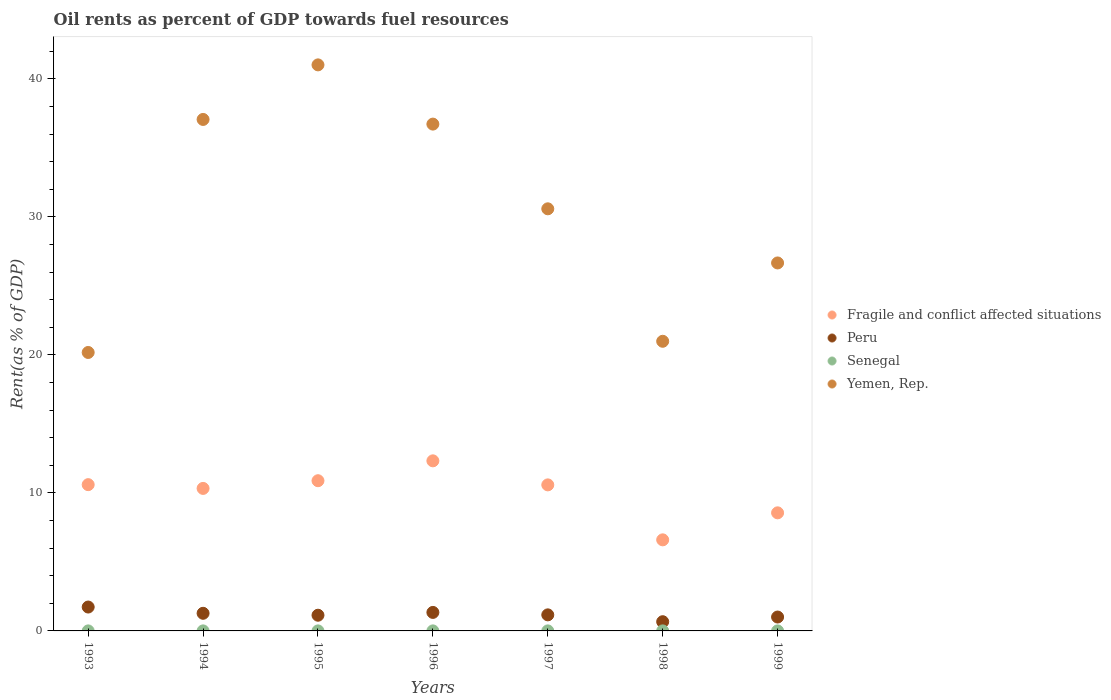How many different coloured dotlines are there?
Your answer should be compact. 4. Is the number of dotlines equal to the number of legend labels?
Make the answer very short. Yes. What is the oil rent in Senegal in 1998?
Provide a short and direct response. 0. Across all years, what is the maximum oil rent in Yemen, Rep.?
Keep it short and to the point. 41.02. Across all years, what is the minimum oil rent in Senegal?
Give a very brief answer. 0. What is the total oil rent in Senegal in the graph?
Offer a very short reply. 0.02. What is the difference between the oil rent in Peru in 1993 and that in 1997?
Keep it short and to the point. 0.57. What is the difference between the oil rent in Yemen, Rep. in 1998 and the oil rent in Fragile and conflict affected situations in 1994?
Ensure brevity in your answer.  10.66. What is the average oil rent in Fragile and conflict affected situations per year?
Make the answer very short. 9.98. In the year 1997, what is the difference between the oil rent in Fragile and conflict affected situations and oil rent in Peru?
Keep it short and to the point. 9.42. What is the ratio of the oil rent in Senegal in 1998 to that in 1999?
Offer a very short reply. 1.41. Is the oil rent in Fragile and conflict affected situations in 1996 less than that in 1999?
Your answer should be compact. No. Is the difference between the oil rent in Fragile and conflict affected situations in 1998 and 1999 greater than the difference between the oil rent in Peru in 1998 and 1999?
Offer a terse response. No. What is the difference between the highest and the second highest oil rent in Peru?
Your response must be concise. 0.39. What is the difference between the highest and the lowest oil rent in Yemen, Rep.?
Your response must be concise. 20.84. In how many years, is the oil rent in Peru greater than the average oil rent in Peru taken over all years?
Your response must be concise. 3. Is the oil rent in Senegal strictly less than the oil rent in Fragile and conflict affected situations over the years?
Provide a succinct answer. Yes. How many years are there in the graph?
Give a very brief answer. 7. Are the values on the major ticks of Y-axis written in scientific E-notation?
Offer a terse response. No. Does the graph contain grids?
Provide a succinct answer. No. Where does the legend appear in the graph?
Offer a very short reply. Center right. How are the legend labels stacked?
Provide a short and direct response. Vertical. What is the title of the graph?
Provide a short and direct response. Oil rents as percent of GDP towards fuel resources. Does "Cayman Islands" appear as one of the legend labels in the graph?
Keep it short and to the point. No. What is the label or title of the Y-axis?
Give a very brief answer. Rent(as % of GDP). What is the Rent(as % of GDP) of Fragile and conflict affected situations in 1993?
Provide a short and direct response. 10.6. What is the Rent(as % of GDP) of Peru in 1993?
Your answer should be compact. 1.73. What is the Rent(as % of GDP) in Senegal in 1993?
Offer a terse response. 0. What is the Rent(as % of GDP) of Yemen, Rep. in 1993?
Offer a terse response. 20.18. What is the Rent(as % of GDP) in Fragile and conflict affected situations in 1994?
Offer a terse response. 10.33. What is the Rent(as % of GDP) of Peru in 1994?
Offer a terse response. 1.28. What is the Rent(as % of GDP) in Senegal in 1994?
Ensure brevity in your answer.  0. What is the Rent(as % of GDP) of Yemen, Rep. in 1994?
Your answer should be compact. 37.06. What is the Rent(as % of GDP) of Fragile and conflict affected situations in 1995?
Provide a short and direct response. 10.88. What is the Rent(as % of GDP) in Peru in 1995?
Ensure brevity in your answer.  1.14. What is the Rent(as % of GDP) in Senegal in 1995?
Your answer should be very brief. 0. What is the Rent(as % of GDP) in Yemen, Rep. in 1995?
Offer a very short reply. 41.02. What is the Rent(as % of GDP) of Fragile and conflict affected situations in 1996?
Your response must be concise. 12.32. What is the Rent(as % of GDP) of Peru in 1996?
Offer a very short reply. 1.34. What is the Rent(as % of GDP) in Senegal in 1996?
Make the answer very short. 0. What is the Rent(as % of GDP) in Yemen, Rep. in 1996?
Ensure brevity in your answer.  36.72. What is the Rent(as % of GDP) of Fragile and conflict affected situations in 1997?
Provide a succinct answer. 10.58. What is the Rent(as % of GDP) of Peru in 1997?
Your answer should be very brief. 1.16. What is the Rent(as % of GDP) in Senegal in 1997?
Your answer should be very brief. 0. What is the Rent(as % of GDP) of Yemen, Rep. in 1997?
Your response must be concise. 30.59. What is the Rent(as % of GDP) of Fragile and conflict affected situations in 1998?
Your answer should be compact. 6.6. What is the Rent(as % of GDP) of Peru in 1998?
Ensure brevity in your answer.  0.67. What is the Rent(as % of GDP) of Senegal in 1998?
Ensure brevity in your answer.  0. What is the Rent(as % of GDP) of Yemen, Rep. in 1998?
Provide a short and direct response. 20.99. What is the Rent(as % of GDP) in Fragile and conflict affected situations in 1999?
Your response must be concise. 8.56. What is the Rent(as % of GDP) in Peru in 1999?
Provide a succinct answer. 1.01. What is the Rent(as % of GDP) in Senegal in 1999?
Your answer should be very brief. 0. What is the Rent(as % of GDP) in Yemen, Rep. in 1999?
Offer a terse response. 26.66. Across all years, what is the maximum Rent(as % of GDP) of Fragile and conflict affected situations?
Give a very brief answer. 12.32. Across all years, what is the maximum Rent(as % of GDP) in Peru?
Ensure brevity in your answer.  1.73. Across all years, what is the maximum Rent(as % of GDP) in Senegal?
Provide a short and direct response. 0. Across all years, what is the maximum Rent(as % of GDP) of Yemen, Rep.?
Offer a very short reply. 41.02. Across all years, what is the minimum Rent(as % of GDP) in Fragile and conflict affected situations?
Ensure brevity in your answer.  6.6. Across all years, what is the minimum Rent(as % of GDP) of Peru?
Your answer should be compact. 0.67. Across all years, what is the minimum Rent(as % of GDP) of Senegal?
Ensure brevity in your answer.  0. Across all years, what is the minimum Rent(as % of GDP) in Yemen, Rep.?
Provide a succinct answer. 20.18. What is the total Rent(as % of GDP) of Fragile and conflict affected situations in the graph?
Offer a very short reply. 69.87. What is the total Rent(as % of GDP) of Peru in the graph?
Provide a short and direct response. 8.32. What is the total Rent(as % of GDP) of Senegal in the graph?
Provide a short and direct response. 0.02. What is the total Rent(as % of GDP) in Yemen, Rep. in the graph?
Offer a very short reply. 213.21. What is the difference between the Rent(as % of GDP) of Fragile and conflict affected situations in 1993 and that in 1994?
Provide a short and direct response. 0.27. What is the difference between the Rent(as % of GDP) in Peru in 1993 and that in 1994?
Give a very brief answer. 0.45. What is the difference between the Rent(as % of GDP) of Senegal in 1993 and that in 1994?
Ensure brevity in your answer.  -0. What is the difference between the Rent(as % of GDP) in Yemen, Rep. in 1993 and that in 1994?
Provide a succinct answer. -16.88. What is the difference between the Rent(as % of GDP) of Fragile and conflict affected situations in 1993 and that in 1995?
Your answer should be compact. -0.28. What is the difference between the Rent(as % of GDP) in Peru in 1993 and that in 1995?
Your answer should be compact. 0.59. What is the difference between the Rent(as % of GDP) of Senegal in 1993 and that in 1995?
Give a very brief answer. -0. What is the difference between the Rent(as % of GDP) in Yemen, Rep. in 1993 and that in 1995?
Make the answer very short. -20.84. What is the difference between the Rent(as % of GDP) of Fragile and conflict affected situations in 1993 and that in 1996?
Your answer should be very brief. -1.73. What is the difference between the Rent(as % of GDP) of Peru in 1993 and that in 1996?
Ensure brevity in your answer.  0.39. What is the difference between the Rent(as % of GDP) in Senegal in 1993 and that in 1996?
Your response must be concise. -0. What is the difference between the Rent(as % of GDP) of Yemen, Rep. in 1993 and that in 1996?
Give a very brief answer. -16.55. What is the difference between the Rent(as % of GDP) of Fragile and conflict affected situations in 1993 and that in 1997?
Offer a very short reply. 0.02. What is the difference between the Rent(as % of GDP) in Peru in 1993 and that in 1997?
Your answer should be compact. 0.57. What is the difference between the Rent(as % of GDP) in Senegal in 1993 and that in 1997?
Offer a very short reply. -0. What is the difference between the Rent(as % of GDP) in Yemen, Rep. in 1993 and that in 1997?
Make the answer very short. -10.41. What is the difference between the Rent(as % of GDP) in Fragile and conflict affected situations in 1993 and that in 1998?
Your answer should be very brief. 4. What is the difference between the Rent(as % of GDP) in Peru in 1993 and that in 1998?
Offer a terse response. 1.06. What is the difference between the Rent(as % of GDP) in Senegal in 1993 and that in 1998?
Your answer should be very brief. -0. What is the difference between the Rent(as % of GDP) of Yemen, Rep. in 1993 and that in 1998?
Make the answer very short. -0.81. What is the difference between the Rent(as % of GDP) in Fragile and conflict affected situations in 1993 and that in 1999?
Your response must be concise. 2.04. What is the difference between the Rent(as % of GDP) in Peru in 1993 and that in 1999?
Give a very brief answer. 0.72. What is the difference between the Rent(as % of GDP) of Senegal in 1993 and that in 1999?
Ensure brevity in your answer.  -0. What is the difference between the Rent(as % of GDP) in Yemen, Rep. in 1993 and that in 1999?
Ensure brevity in your answer.  -6.49. What is the difference between the Rent(as % of GDP) in Fragile and conflict affected situations in 1994 and that in 1995?
Give a very brief answer. -0.56. What is the difference between the Rent(as % of GDP) of Peru in 1994 and that in 1995?
Provide a succinct answer. 0.14. What is the difference between the Rent(as % of GDP) in Senegal in 1994 and that in 1995?
Provide a short and direct response. 0. What is the difference between the Rent(as % of GDP) in Yemen, Rep. in 1994 and that in 1995?
Ensure brevity in your answer.  -3.95. What is the difference between the Rent(as % of GDP) in Fragile and conflict affected situations in 1994 and that in 1996?
Ensure brevity in your answer.  -2. What is the difference between the Rent(as % of GDP) in Peru in 1994 and that in 1996?
Give a very brief answer. -0.06. What is the difference between the Rent(as % of GDP) of Senegal in 1994 and that in 1996?
Your response must be concise. -0. What is the difference between the Rent(as % of GDP) of Yemen, Rep. in 1994 and that in 1996?
Keep it short and to the point. 0.34. What is the difference between the Rent(as % of GDP) in Fragile and conflict affected situations in 1994 and that in 1997?
Offer a terse response. -0.26. What is the difference between the Rent(as % of GDP) of Peru in 1994 and that in 1997?
Ensure brevity in your answer.  0.11. What is the difference between the Rent(as % of GDP) in Senegal in 1994 and that in 1997?
Your answer should be compact. -0. What is the difference between the Rent(as % of GDP) in Yemen, Rep. in 1994 and that in 1997?
Offer a terse response. 6.48. What is the difference between the Rent(as % of GDP) in Fragile and conflict affected situations in 1994 and that in 1998?
Offer a very short reply. 3.73. What is the difference between the Rent(as % of GDP) of Peru in 1994 and that in 1998?
Offer a very short reply. 0.61. What is the difference between the Rent(as % of GDP) of Senegal in 1994 and that in 1998?
Provide a short and direct response. -0. What is the difference between the Rent(as % of GDP) in Yemen, Rep. in 1994 and that in 1998?
Give a very brief answer. 16.07. What is the difference between the Rent(as % of GDP) in Fragile and conflict affected situations in 1994 and that in 1999?
Provide a short and direct response. 1.77. What is the difference between the Rent(as % of GDP) of Peru in 1994 and that in 1999?
Offer a terse response. 0.27. What is the difference between the Rent(as % of GDP) in Senegal in 1994 and that in 1999?
Your answer should be compact. 0. What is the difference between the Rent(as % of GDP) of Yemen, Rep. in 1994 and that in 1999?
Make the answer very short. 10.4. What is the difference between the Rent(as % of GDP) in Fragile and conflict affected situations in 1995 and that in 1996?
Ensure brevity in your answer.  -1.44. What is the difference between the Rent(as % of GDP) of Peru in 1995 and that in 1996?
Provide a short and direct response. -0.2. What is the difference between the Rent(as % of GDP) of Senegal in 1995 and that in 1996?
Your response must be concise. -0. What is the difference between the Rent(as % of GDP) of Yemen, Rep. in 1995 and that in 1996?
Keep it short and to the point. 4.29. What is the difference between the Rent(as % of GDP) of Fragile and conflict affected situations in 1995 and that in 1997?
Ensure brevity in your answer.  0.3. What is the difference between the Rent(as % of GDP) of Peru in 1995 and that in 1997?
Offer a terse response. -0.03. What is the difference between the Rent(as % of GDP) in Senegal in 1995 and that in 1997?
Keep it short and to the point. -0. What is the difference between the Rent(as % of GDP) of Yemen, Rep. in 1995 and that in 1997?
Your answer should be very brief. 10.43. What is the difference between the Rent(as % of GDP) of Fragile and conflict affected situations in 1995 and that in 1998?
Make the answer very short. 4.28. What is the difference between the Rent(as % of GDP) in Peru in 1995 and that in 1998?
Your answer should be compact. 0.47. What is the difference between the Rent(as % of GDP) of Senegal in 1995 and that in 1998?
Give a very brief answer. -0. What is the difference between the Rent(as % of GDP) in Yemen, Rep. in 1995 and that in 1998?
Give a very brief answer. 20.03. What is the difference between the Rent(as % of GDP) in Fragile and conflict affected situations in 1995 and that in 1999?
Your response must be concise. 2.33. What is the difference between the Rent(as % of GDP) in Peru in 1995 and that in 1999?
Offer a terse response. 0.13. What is the difference between the Rent(as % of GDP) in Yemen, Rep. in 1995 and that in 1999?
Provide a succinct answer. 14.35. What is the difference between the Rent(as % of GDP) of Fragile and conflict affected situations in 1996 and that in 1997?
Your answer should be compact. 1.74. What is the difference between the Rent(as % of GDP) in Peru in 1996 and that in 1997?
Offer a terse response. 0.18. What is the difference between the Rent(as % of GDP) in Yemen, Rep. in 1996 and that in 1997?
Provide a short and direct response. 6.14. What is the difference between the Rent(as % of GDP) of Fragile and conflict affected situations in 1996 and that in 1998?
Keep it short and to the point. 5.72. What is the difference between the Rent(as % of GDP) in Peru in 1996 and that in 1998?
Your answer should be compact. 0.67. What is the difference between the Rent(as % of GDP) in Senegal in 1996 and that in 1998?
Give a very brief answer. -0. What is the difference between the Rent(as % of GDP) in Yemen, Rep. in 1996 and that in 1998?
Offer a terse response. 15.74. What is the difference between the Rent(as % of GDP) in Fragile and conflict affected situations in 1996 and that in 1999?
Your answer should be very brief. 3.77. What is the difference between the Rent(as % of GDP) of Peru in 1996 and that in 1999?
Your response must be concise. 0.33. What is the difference between the Rent(as % of GDP) in Yemen, Rep. in 1996 and that in 1999?
Offer a very short reply. 10.06. What is the difference between the Rent(as % of GDP) in Fragile and conflict affected situations in 1997 and that in 1998?
Provide a succinct answer. 3.98. What is the difference between the Rent(as % of GDP) of Peru in 1997 and that in 1998?
Make the answer very short. 0.5. What is the difference between the Rent(as % of GDP) of Senegal in 1997 and that in 1998?
Your answer should be very brief. -0. What is the difference between the Rent(as % of GDP) in Yemen, Rep. in 1997 and that in 1998?
Provide a succinct answer. 9.6. What is the difference between the Rent(as % of GDP) in Fragile and conflict affected situations in 1997 and that in 1999?
Make the answer very short. 2.03. What is the difference between the Rent(as % of GDP) in Peru in 1997 and that in 1999?
Provide a short and direct response. 0.16. What is the difference between the Rent(as % of GDP) of Yemen, Rep. in 1997 and that in 1999?
Make the answer very short. 3.92. What is the difference between the Rent(as % of GDP) of Fragile and conflict affected situations in 1998 and that in 1999?
Your response must be concise. -1.96. What is the difference between the Rent(as % of GDP) in Peru in 1998 and that in 1999?
Your answer should be very brief. -0.34. What is the difference between the Rent(as % of GDP) in Senegal in 1998 and that in 1999?
Offer a very short reply. 0. What is the difference between the Rent(as % of GDP) in Yemen, Rep. in 1998 and that in 1999?
Your response must be concise. -5.68. What is the difference between the Rent(as % of GDP) in Fragile and conflict affected situations in 1993 and the Rent(as % of GDP) in Peru in 1994?
Provide a succinct answer. 9.32. What is the difference between the Rent(as % of GDP) in Fragile and conflict affected situations in 1993 and the Rent(as % of GDP) in Senegal in 1994?
Make the answer very short. 10.6. What is the difference between the Rent(as % of GDP) in Fragile and conflict affected situations in 1993 and the Rent(as % of GDP) in Yemen, Rep. in 1994?
Offer a terse response. -26.46. What is the difference between the Rent(as % of GDP) of Peru in 1993 and the Rent(as % of GDP) of Senegal in 1994?
Make the answer very short. 1.73. What is the difference between the Rent(as % of GDP) in Peru in 1993 and the Rent(as % of GDP) in Yemen, Rep. in 1994?
Your response must be concise. -35.33. What is the difference between the Rent(as % of GDP) in Senegal in 1993 and the Rent(as % of GDP) in Yemen, Rep. in 1994?
Offer a very short reply. -37.06. What is the difference between the Rent(as % of GDP) of Fragile and conflict affected situations in 1993 and the Rent(as % of GDP) of Peru in 1995?
Keep it short and to the point. 9.46. What is the difference between the Rent(as % of GDP) in Fragile and conflict affected situations in 1993 and the Rent(as % of GDP) in Senegal in 1995?
Offer a very short reply. 10.6. What is the difference between the Rent(as % of GDP) of Fragile and conflict affected situations in 1993 and the Rent(as % of GDP) of Yemen, Rep. in 1995?
Your response must be concise. -30.42. What is the difference between the Rent(as % of GDP) in Peru in 1993 and the Rent(as % of GDP) in Senegal in 1995?
Your response must be concise. 1.73. What is the difference between the Rent(as % of GDP) in Peru in 1993 and the Rent(as % of GDP) in Yemen, Rep. in 1995?
Ensure brevity in your answer.  -39.28. What is the difference between the Rent(as % of GDP) of Senegal in 1993 and the Rent(as % of GDP) of Yemen, Rep. in 1995?
Make the answer very short. -41.01. What is the difference between the Rent(as % of GDP) of Fragile and conflict affected situations in 1993 and the Rent(as % of GDP) of Peru in 1996?
Your answer should be compact. 9.26. What is the difference between the Rent(as % of GDP) in Fragile and conflict affected situations in 1993 and the Rent(as % of GDP) in Senegal in 1996?
Offer a terse response. 10.6. What is the difference between the Rent(as % of GDP) in Fragile and conflict affected situations in 1993 and the Rent(as % of GDP) in Yemen, Rep. in 1996?
Provide a succinct answer. -26.12. What is the difference between the Rent(as % of GDP) in Peru in 1993 and the Rent(as % of GDP) in Senegal in 1996?
Give a very brief answer. 1.73. What is the difference between the Rent(as % of GDP) of Peru in 1993 and the Rent(as % of GDP) of Yemen, Rep. in 1996?
Offer a terse response. -34.99. What is the difference between the Rent(as % of GDP) of Senegal in 1993 and the Rent(as % of GDP) of Yemen, Rep. in 1996?
Give a very brief answer. -36.72. What is the difference between the Rent(as % of GDP) of Fragile and conflict affected situations in 1993 and the Rent(as % of GDP) of Peru in 1997?
Your answer should be very brief. 9.43. What is the difference between the Rent(as % of GDP) of Fragile and conflict affected situations in 1993 and the Rent(as % of GDP) of Senegal in 1997?
Your response must be concise. 10.6. What is the difference between the Rent(as % of GDP) in Fragile and conflict affected situations in 1993 and the Rent(as % of GDP) in Yemen, Rep. in 1997?
Your response must be concise. -19.99. What is the difference between the Rent(as % of GDP) of Peru in 1993 and the Rent(as % of GDP) of Senegal in 1997?
Make the answer very short. 1.73. What is the difference between the Rent(as % of GDP) of Peru in 1993 and the Rent(as % of GDP) of Yemen, Rep. in 1997?
Make the answer very short. -28.86. What is the difference between the Rent(as % of GDP) of Senegal in 1993 and the Rent(as % of GDP) of Yemen, Rep. in 1997?
Give a very brief answer. -30.58. What is the difference between the Rent(as % of GDP) of Fragile and conflict affected situations in 1993 and the Rent(as % of GDP) of Peru in 1998?
Offer a terse response. 9.93. What is the difference between the Rent(as % of GDP) of Fragile and conflict affected situations in 1993 and the Rent(as % of GDP) of Senegal in 1998?
Offer a terse response. 10.6. What is the difference between the Rent(as % of GDP) in Fragile and conflict affected situations in 1993 and the Rent(as % of GDP) in Yemen, Rep. in 1998?
Keep it short and to the point. -10.39. What is the difference between the Rent(as % of GDP) of Peru in 1993 and the Rent(as % of GDP) of Senegal in 1998?
Offer a very short reply. 1.73. What is the difference between the Rent(as % of GDP) in Peru in 1993 and the Rent(as % of GDP) in Yemen, Rep. in 1998?
Offer a very short reply. -19.26. What is the difference between the Rent(as % of GDP) in Senegal in 1993 and the Rent(as % of GDP) in Yemen, Rep. in 1998?
Provide a short and direct response. -20.99. What is the difference between the Rent(as % of GDP) in Fragile and conflict affected situations in 1993 and the Rent(as % of GDP) in Peru in 1999?
Provide a short and direct response. 9.59. What is the difference between the Rent(as % of GDP) in Fragile and conflict affected situations in 1993 and the Rent(as % of GDP) in Senegal in 1999?
Offer a terse response. 10.6. What is the difference between the Rent(as % of GDP) of Fragile and conflict affected situations in 1993 and the Rent(as % of GDP) of Yemen, Rep. in 1999?
Your response must be concise. -16.06. What is the difference between the Rent(as % of GDP) of Peru in 1993 and the Rent(as % of GDP) of Senegal in 1999?
Provide a short and direct response. 1.73. What is the difference between the Rent(as % of GDP) of Peru in 1993 and the Rent(as % of GDP) of Yemen, Rep. in 1999?
Offer a very short reply. -24.93. What is the difference between the Rent(as % of GDP) in Senegal in 1993 and the Rent(as % of GDP) in Yemen, Rep. in 1999?
Ensure brevity in your answer.  -26.66. What is the difference between the Rent(as % of GDP) of Fragile and conflict affected situations in 1994 and the Rent(as % of GDP) of Peru in 1995?
Give a very brief answer. 9.19. What is the difference between the Rent(as % of GDP) of Fragile and conflict affected situations in 1994 and the Rent(as % of GDP) of Senegal in 1995?
Keep it short and to the point. 10.32. What is the difference between the Rent(as % of GDP) in Fragile and conflict affected situations in 1994 and the Rent(as % of GDP) in Yemen, Rep. in 1995?
Offer a terse response. -30.69. What is the difference between the Rent(as % of GDP) in Peru in 1994 and the Rent(as % of GDP) in Senegal in 1995?
Give a very brief answer. 1.27. What is the difference between the Rent(as % of GDP) of Peru in 1994 and the Rent(as % of GDP) of Yemen, Rep. in 1995?
Your answer should be very brief. -39.74. What is the difference between the Rent(as % of GDP) in Senegal in 1994 and the Rent(as % of GDP) in Yemen, Rep. in 1995?
Provide a short and direct response. -41.01. What is the difference between the Rent(as % of GDP) of Fragile and conflict affected situations in 1994 and the Rent(as % of GDP) of Peru in 1996?
Your answer should be compact. 8.99. What is the difference between the Rent(as % of GDP) in Fragile and conflict affected situations in 1994 and the Rent(as % of GDP) in Senegal in 1996?
Provide a succinct answer. 10.32. What is the difference between the Rent(as % of GDP) of Fragile and conflict affected situations in 1994 and the Rent(as % of GDP) of Yemen, Rep. in 1996?
Your answer should be compact. -26.4. What is the difference between the Rent(as % of GDP) of Peru in 1994 and the Rent(as % of GDP) of Senegal in 1996?
Provide a short and direct response. 1.27. What is the difference between the Rent(as % of GDP) in Peru in 1994 and the Rent(as % of GDP) in Yemen, Rep. in 1996?
Offer a terse response. -35.45. What is the difference between the Rent(as % of GDP) in Senegal in 1994 and the Rent(as % of GDP) in Yemen, Rep. in 1996?
Your answer should be very brief. -36.72. What is the difference between the Rent(as % of GDP) in Fragile and conflict affected situations in 1994 and the Rent(as % of GDP) in Peru in 1997?
Keep it short and to the point. 9.16. What is the difference between the Rent(as % of GDP) in Fragile and conflict affected situations in 1994 and the Rent(as % of GDP) in Senegal in 1997?
Keep it short and to the point. 10.32. What is the difference between the Rent(as % of GDP) of Fragile and conflict affected situations in 1994 and the Rent(as % of GDP) of Yemen, Rep. in 1997?
Provide a short and direct response. -20.26. What is the difference between the Rent(as % of GDP) of Peru in 1994 and the Rent(as % of GDP) of Senegal in 1997?
Provide a succinct answer. 1.27. What is the difference between the Rent(as % of GDP) in Peru in 1994 and the Rent(as % of GDP) in Yemen, Rep. in 1997?
Offer a very short reply. -29.31. What is the difference between the Rent(as % of GDP) of Senegal in 1994 and the Rent(as % of GDP) of Yemen, Rep. in 1997?
Ensure brevity in your answer.  -30.58. What is the difference between the Rent(as % of GDP) in Fragile and conflict affected situations in 1994 and the Rent(as % of GDP) in Peru in 1998?
Provide a short and direct response. 9.66. What is the difference between the Rent(as % of GDP) in Fragile and conflict affected situations in 1994 and the Rent(as % of GDP) in Senegal in 1998?
Provide a succinct answer. 10.32. What is the difference between the Rent(as % of GDP) of Fragile and conflict affected situations in 1994 and the Rent(as % of GDP) of Yemen, Rep. in 1998?
Provide a short and direct response. -10.66. What is the difference between the Rent(as % of GDP) in Peru in 1994 and the Rent(as % of GDP) in Senegal in 1998?
Offer a very short reply. 1.27. What is the difference between the Rent(as % of GDP) of Peru in 1994 and the Rent(as % of GDP) of Yemen, Rep. in 1998?
Offer a very short reply. -19.71. What is the difference between the Rent(as % of GDP) in Senegal in 1994 and the Rent(as % of GDP) in Yemen, Rep. in 1998?
Provide a short and direct response. -20.98. What is the difference between the Rent(as % of GDP) of Fragile and conflict affected situations in 1994 and the Rent(as % of GDP) of Peru in 1999?
Give a very brief answer. 9.32. What is the difference between the Rent(as % of GDP) in Fragile and conflict affected situations in 1994 and the Rent(as % of GDP) in Senegal in 1999?
Keep it short and to the point. 10.32. What is the difference between the Rent(as % of GDP) in Fragile and conflict affected situations in 1994 and the Rent(as % of GDP) in Yemen, Rep. in 1999?
Ensure brevity in your answer.  -16.34. What is the difference between the Rent(as % of GDP) in Peru in 1994 and the Rent(as % of GDP) in Senegal in 1999?
Your answer should be compact. 1.28. What is the difference between the Rent(as % of GDP) of Peru in 1994 and the Rent(as % of GDP) of Yemen, Rep. in 1999?
Keep it short and to the point. -25.39. What is the difference between the Rent(as % of GDP) in Senegal in 1994 and the Rent(as % of GDP) in Yemen, Rep. in 1999?
Give a very brief answer. -26.66. What is the difference between the Rent(as % of GDP) of Fragile and conflict affected situations in 1995 and the Rent(as % of GDP) of Peru in 1996?
Provide a short and direct response. 9.54. What is the difference between the Rent(as % of GDP) in Fragile and conflict affected situations in 1995 and the Rent(as % of GDP) in Senegal in 1996?
Make the answer very short. 10.88. What is the difference between the Rent(as % of GDP) in Fragile and conflict affected situations in 1995 and the Rent(as % of GDP) in Yemen, Rep. in 1996?
Provide a short and direct response. -25.84. What is the difference between the Rent(as % of GDP) of Peru in 1995 and the Rent(as % of GDP) of Senegal in 1996?
Give a very brief answer. 1.14. What is the difference between the Rent(as % of GDP) of Peru in 1995 and the Rent(as % of GDP) of Yemen, Rep. in 1996?
Offer a very short reply. -35.59. What is the difference between the Rent(as % of GDP) in Senegal in 1995 and the Rent(as % of GDP) in Yemen, Rep. in 1996?
Keep it short and to the point. -36.72. What is the difference between the Rent(as % of GDP) of Fragile and conflict affected situations in 1995 and the Rent(as % of GDP) of Peru in 1997?
Provide a short and direct response. 9.72. What is the difference between the Rent(as % of GDP) in Fragile and conflict affected situations in 1995 and the Rent(as % of GDP) in Senegal in 1997?
Give a very brief answer. 10.88. What is the difference between the Rent(as % of GDP) in Fragile and conflict affected situations in 1995 and the Rent(as % of GDP) in Yemen, Rep. in 1997?
Your answer should be compact. -19.7. What is the difference between the Rent(as % of GDP) of Peru in 1995 and the Rent(as % of GDP) of Senegal in 1997?
Your answer should be very brief. 1.14. What is the difference between the Rent(as % of GDP) of Peru in 1995 and the Rent(as % of GDP) of Yemen, Rep. in 1997?
Your answer should be compact. -29.45. What is the difference between the Rent(as % of GDP) of Senegal in 1995 and the Rent(as % of GDP) of Yemen, Rep. in 1997?
Your response must be concise. -30.58. What is the difference between the Rent(as % of GDP) of Fragile and conflict affected situations in 1995 and the Rent(as % of GDP) of Peru in 1998?
Offer a very short reply. 10.22. What is the difference between the Rent(as % of GDP) of Fragile and conflict affected situations in 1995 and the Rent(as % of GDP) of Senegal in 1998?
Keep it short and to the point. 10.88. What is the difference between the Rent(as % of GDP) in Fragile and conflict affected situations in 1995 and the Rent(as % of GDP) in Yemen, Rep. in 1998?
Provide a succinct answer. -10.1. What is the difference between the Rent(as % of GDP) of Peru in 1995 and the Rent(as % of GDP) of Senegal in 1998?
Offer a terse response. 1.13. What is the difference between the Rent(as % of GDP) of Peru in 1995 and the Rent(as % of GDP) of Yemen, Rep. in 1998?
Keep it short and to the point. -19.85. What is the difference between the Rent(as % of GDP) in Senegal in 1995 and the Rent(as % of GDP) in Yemen, Rep. in 1998?
Offer a very short reply. -20.99. What is the difference between the Rent(as % of GDP) in Fragile and conflict affected situations in 1995 and the Rent(as % of GDP) in Peru in 1999?
Keep it short and to the point. 9.88. What is the difference between the Rent(as % of GDP) in Fragile and conflict affected situations in 1995 and the Rent(as % of GDP) in Senegal in 1999?
Your response must be concise. 10.88. What is the difference between the Rent(as % of GDP) in Fragile and conflict affected situations in 1995 and the Rent(as % of GDP) in Yemen, Rep. in 1999?
Your response must be concise. -15.78. What is the difference between the Rent(as % of GDP) in Peru in 1995 and the Rent(as % of GDP) in Senegal in 1999?
Your response must be concise. 1.14. What is the difference between the Rent(as % of GDP) of Peru in 1995 and the Rent(as % of GDP) of Yemen, Rep. in 1999?
Provide a succinct answer. -25.53. What is the difference between the Rent(as % of GDP) in Senegal in 1995 and the Rent(as % of GDP) in Yemen, Rep. in 1999?
Offer a terse response. -26.66. What is the difference between the Rent(as % of GDP) in Fragile and conflict affected situations in 1996 and the Rent(as % of GDP) in Peru in 1997?
Your answer should be compact. 11.16. What is the difference between the Rent(as % of GDP) of Fragile and conflict affected situations in 1996 and the Rent(as % of GDP) of Senegal in 1997?
Keep it short and to the point. 12.32. What is the difference between the Rent(as % of GDP) of Fragile and conflict affected situations in 1996 and the Rent(as % of GDP) of Yemen, Rep. in 1997?
Your answer should be very brief. -18.26. What is the difference between the Rent(as % of GDP) of Peru in 1996 and the Rent(as % of GDP) of Senegal in 1997?
Make the answer very short. 1.34. What is the difference between the Rent(as % of GDP) of Peru in 1996 and the Rent(as % of GDP) of Yemen, Rep. in 1997?
Make the answer very short. -29.25. What is the difference between the Rent(as % of GDP) of Senegal in 1996 and the Rent(as % of GDP) of Yemen, Rep. in 1997?
Make the answer very short. -30.58. What is the difference between the Rent(as % of GDP) in Fragile and conflict affected situations in 1996 and the Rent(as % of GDP) in Peru in 1998?
Keep it short and to the point. 11.66. What is the difference between the Rent(as % of GDP) of Fragile and conflict affected situations in 1996 and the Rent(as % of GDP) of Senegal in 1998?
Ensure brevity in your answer.  12.32. What is the difference between the Rent(as % of GDP) of Fragile and conflict affected situations in 1996 and the Rent(as % of GDP) of Yemen, Rep. in 1998?
Provide a succinct answer. -8.66. What is the difference between the Rent(as % of GDP) in Peru in 1996 and the Rent(as % of GDP) in Senegal in 1998?
Give a very brief answer. 1.34. What is the difference between the Rent(as % of GDP) in Peru in 1996 and the Rent(as % of GDP) in Yemen, Rep. in 1998?
Give a very brief answer. -19.65. What is the difference between the Rent(as % of GDP) of Senegal in 1996 and the Rent(as % of GDP) of Yemen, Rep. in 1998?
Your answer should be very brief. -20.98. What is the difference between the Rent(as % of GDP) in Fragile and conflict affected situations in 1996 and the Rent(as % of GDP) in Peru in 1999?
Your answer should be compact. 11.32. What is the difference between the Rent(as % of GDP) in Fragile and conflict affected situations in 1996 and the Rent(as % of GDP) in Senegal in 1999?
Give a very brief answer. 12.32. What is the difference between the Rent(as % of GDP) of Fragile and conflict affected situations in 1996 and the Rent(as % of GDP) of Yemen, Rep. in 1999?
Give a very brief answer. -14.34. What is the difference between the Rent(as % of GDP) in Peru in 1996 and the Rent(as % of GDP) in Senegal in 1999?
Your answer should be very brief. 1.34. What is the difference between the Rent(as % of GDP) of Peru in 1996 and the Rent(as % of GDP) of Yemen, Rep. in 1999?
Offer a very short reply. -25.32. What is the difference between the Rent(as % of GDP) of Senegal in 1996 and the Rent(as % of GDP) of Yemen, Rep. in 1999?
Offer a very short reply. -26.66. What is the difference between the Rent(as % of GDP) in Fragile and conflict affected situations in 1997 and the Rent(as % of GDP) in Peru in 1998?
Give a very brief answer. 9.91. What is the difference between the Rent(as % of GDP) of Fragile and conflict affected situations in 1997 and the Rent(as % of GDP) of Senegal in 1998?
Your answer should be very brief. 10.58. What is the difference between the Rent(as % of GDP) of Fragile and conflict affected situations in 1997 and the Rent(as % of GDP) of Yemen, Rep. in 1998?
Make the answer very short. -10.4. What is the difference between the Rent(as % of GDP) of Peru in 1997 and the Rent(as % of GDP) of Senegal in 1998?
Provide a short and direct response. 1.16. What is the difference between the Rent(as % of GDP) of Peru in 1997 and the Rent(as % of GDP) of Yemen, Rep. in 1998?
Give a very brief answer. -19.82. What is the difference between the Rent(as % of GDP) in Senegal in 1997 and the Rent(as % of GDP) in Yemen, Rep. in 1998?
Make the answer very short. -20.98. What is the difference between the Rent(as % of GDP) in Fragile and conflict affected situations in 1997 and the Rent(as % of GDP) in Peru in 1999?
Offer a terse response. 9.58. What is the difference between the Rent(as % of GDP) of Fragile and conflict affected situations in 1997 and the Rent(as % of GDP) of Senegal in 1999?
Offer a very short reply. 10.58. What is the difference between the Rent(as % of GDP) in Fragile and conflict affected situations in 1997 and the Rent(as % of GDP) in Yemen, Rep. in 1999?
Offer a terse response. -16.08. What is the difference between the Rent(as % of GDP) of Peru in 1997 and the Rent(as % of GDP) of Senegal in 1999?
Provide a short and direct response. 1.16. What is the difference between the Rent(as % of GDP) in Peru in 1997 and the Rent(as % of GDP) in Yemen, Rep. in 1999?
Ensure brevity in your answer.  -25.5. What is the difference between the Rent(as % of GDP) in Senegal in 1997 and the Rent(as % of GDP) in Yemen, Rep. in 1999?
Provide a short and direct response. -26.66. What is the difference between the Rent(as % of GDP) of Fragile and conflict affected situations in 1998 and the Rent(as % of GDP) of Peru in 1999?
Provide a succinct answer. 5.59. What is the difference between the Rent(as % of GDP) in Fragile and conflict affected situations in 1998 and the Rent(as % of GDP) in Senegal in 1999?
Your answer should be compact. 6.6. What is the difference between the Rent(as % of GDP) of Fragile and conflict affected situations in 1998 and the Rent(as % of GDP) of Yemen, Rep. in 1999?
Your response must be concise. -20.06. What is the difference between the Rent(as % of GDP) in Peru in 1998 and the Rent(as % of GDP) in Senegal in 1999?
Give a very brief answer. 0.67. What is the difference between the Rent(as % of GDP) of Peru in 1998 and the Rent(as % of GDP) of Yemen, Rep. in 1999?
Provide a succinct answer. -26. What is the difference between the Rent(as % of GDP) of Senegal in 1998 and the Rent(as % of GDP) of Yemen, Rep. in 1999?
Ensure brevity in your answer.  -26.66. What is the average Rent(as % of GDP) in Fragile and conflict affected situations per year?
Offer a very short reply. 9.98. What is the average Rent(as % of GDP) of Peru per year?
Offer a terse response. 1.19. What is the average Rent(as % of GDP) in Senegal per year?
Provide a short and direct response. 0. What is the average Rent(as % of GDP) in Yemen, Rep. per year?
Provide a succinct answer. 30.46. In the year 1993, what is the difference between the Rent(as % of GDP) of Fragile and conflict affected situations and Rent(as % of GDP) of Peru?
Your answer should be compact. 8.87. In the year 1993, what is the difference between the Rent(as % of GDP) of Fragile and conflict affected situations and Rent(as % of GDP) of Senegal?
Offer a terse response. 10.6. In the year 1993, what is the difference between the Rent(as % of GDP) of Fragile and conflict affected situations and Rent(as % of GDP) of Yemen, Rep.?
Provide a succinct answer. -9.58. In the year 1993, what is the difference between the Rent(as % of GDP) of Peru and Rent(as % of GDP) of Senegal?
Keep it short and to the point. 1.73. In the year 1993, what is the difference between the Rent(as % of GDP) in Peru and Rent(as % of GDP) in Yemen, Rep.?
Ensure brevity in your answer.  -18.45. In the year 1993, what is the difference between the Rent(as % of GDP) of Senegal and Rent(as % of GDP) of Yemen, Rep.?
Your answer should be very brief. -20.17. In the year 1994, what is the difference between the Rent(as % of GDP) of Fragile and conflict affected situations and Rent(as % of GDP) of Peru?
Offer a terse response. 9.05. In the year 1994, what is the difference between the Rent(as % of GDP) in Fragile and conflict affected situations and Rent(as % of GDP) in Senegal?
Make the answer very short. 10.32. In the year 1994, what is the difference between the Rent(as % of GDP) of Fragile and conflict affected situations and Rent(as % of GDP) of Yemen, Rep.?
Offer a very short reply. -26.74. In the year 1994, what is the difference between the Rent(as % of GDP) of Peru and Rent(as % of GDP) of Senegal?
Offer a very short reply. 1.27. In the year 1994, what is the difference between the Rent(as % of GDP) in Peru and Rent(as % of GDP) in Yemen, Rep.?
Offer a terse response. -35.78. In the year 1994, what is the difference between the Rent(as % of GDP) of Senegal and Rent(as % of GDP) of Yemen, Rep.?
Make the answer very short. -37.06. In the year 1995, what is the difference between the Rent(as % of GDP) of Fragile and conflict affected situations and Rent(as % of GDP) of Peru?
Provide a succinct answer. 9.75. In the year 1995, what is the difference between the Rent(as % of GDP) of Fragile and conflict affected situations and Rent(as % of GDP) of Senegal?
Your answer should be compact. 10.88. In the year 1995, what is the difference between the Rent(as % of GDP) of Fragile and conflict affected situations and Rent(as % of GDP) of Yemen, Rep.?
Offer a terse response. -30.13. In the year 1995, what is the difference between the Rent(as % of GDP) in Peru and Rent(as % of GDP) in Senegal?
Provide a succinct answer. 1.14. In the year 1995, what is the difference between the Rent(as % of GDP) of Peru and Rent(as % of GDP) of Yemen, Rep.?
Provide a short and direct response. -39.88. In the year 1995, what is the difference between the Rent(as % of GDP) of Senegal and Rent(as % of GDP) of Yemen, Rep.?
Ensure brevity in your answer.  -41.01. In the year 1996, what is the difference between the Rent(as % of GDP) of Fragile and conflict affected situations and Rent(as % of GDP) of Peru?
Provide a short and direct response. 10.98. In the year 1996, what is the difference between the Rent(as % of GDP) in Fragile and conflict affected situations and Rent(as % of GDP) in Senegal?
Provide a short and direct response. 12.32. In the year 1996, what is the difference between the Rent(as % of GDP) in Fragile and conflict affected situations and Rent(as % of GDP) in Yemen, Rep.?
Give a very brief answer. -24.4. In the year 1996, what is the difference between the Rent(as % of GDP) in Peru and Rent(as % of GDP) in Senegal?
Give a very brief answer. 1.34. In the year 1996, what is the difference between the Rent(as % of GDP) of Peru and Rent(as % of GDP) of Yemen, Rep.?
Make the answer very short. -35.38. In the year 1996, what is the difference between the Rent(as % of GDP) of Senegal and Rent(as % of GDP) of Yemen, Rep.?
Provide a short and direct response. -36.72. In the year 1997, what is the difference between the Rent(as % of GDP) in Fragile and conflict affected situations and Rent(as % of GDP) in Peru?
Your answer should be very brief. 9.42. In the year 1997, what is the difference between the Rent(as % of GDP) in Fragile and conflict affected situations and Rent(as % of GDP) in Senegal?
Offer a terse response. 10.58. In the year 1997, what is the difference between the Rent(as % of GDP) of Fragile and conflict affected situations and Rent(as % of GDP) of Yemen, Rep.?
Offer a terse response. -20. In the year 1997, what is the difference between the Rent(as % of GDP) of Peru and Rent(as % of GDP) of Senegal?
Make the answer very short. 1.16. In the year 1997, what is the difference between the Rent(as % of GDP) in Peru and Rent(as % of GDP) in Yemen, Rep.?
Give a very brief answer. -29.42. In the year 1997, what is the difference between the Rent(as % of GDP) of Senegal and Rent(as % of GDP) of Yemen, Rep.?
Offer a very short reply. -30.58. In the year 1998, what is the difference between the Rent(as % of GDP) of Fragile and conflict affected situations and Rent(as % of GDP) of Peru?
Ensure brevity in your answer.  5.93. In the year 1998, what is the difference between the Rent(as % of GDP) in Fragile and conflict affected situations and Rent(as % of GDP) in Senegal?
Ensure brevity in your answer.  6.6. In the year 1998, what is the difference between the Rent(as % of GDP) in Fragile and conflict affected situations and Rent(as % of GDP) in Yemen, Rep.?
Your answer should be very brief. -14.39. In the year 1998, what is the difference between the Rent(as % of GDP) of Peru and Rent(as % of GDP) of Senegal?
Make the answer very short. 0.66. In the year 1998, what is the difference between the Rent(as % of GDP) of Peru and Rent(as % of GDP) of Yemen, Rep.?
Offer a terse response. -20.32. In the year 1998, what is the difference between the Rent(as % of GDP) of Senegal and Rent(as % of GDP) of Yemen, Rep.?
Make the answer very short. -20.98. In the year 1999, what is the difference between the Rent(as % of GDP) in Fragile and conflict affected situations and Rent(as % of GDP) in Peru?
Provide a succinct answer. 7.55. In the year 1999, what is the difference between the Rent(as % of GDP) of Fragile and conflict affected situations and Rent(as % of GDP) of Senegal?
Offer a very short reply. 8.55. In the year 1999, what is the difference between the Rent(as % of GDP) of Fragile and conflict affected situations and Rent(as % of GDP) of Yemen, Rep.?
Your response must be concise. -18.11. In the year 1999, what is the difference between the Rent(as % of GDP) of Peru and Rent(as % of GDP) of Senegal?
Provide a short and direct response. 1. In the year 1999, what is the difference between the Rent(as % of GDP) of Peru and Rent(as % of GDP) of Yemen, Rep.?
Keep it short and to the point. -25.66. In the year 1999, what is the difference between the Rent(as % of GDP) of Senegal and Rent(as % of GDP) of Yemen, Rep.?
Provide a succinct answer. -26.66. What is the ratio of the Rent(as % of GDP) in Fragile and conflict affected situations in 1993 to that in 1994?
Your answer should be compact. 1.03. What is the ratio of the Rent(as % of GDP) in Peru in 1993 to that in 1994?
Your response must be concise. 1.36. What is the ratio of the Rent(as % of GDP) in Senegal in 1993 to that in 1994?
Ensure brevity in your answer.  0.73. What is the ratio of the Rent(as % of GDP) in Yemen, Rep. in 1993 to that in 1994?
Your answer should be compact. 0.54. What is the ratio of the Rent(as % of GDP) in Fragile and conflict affected situations in 1993 to that in 1995?
Your answer should be very brief. 0.97. What is the ratio of the Rent(as % of GDP) of Peru in 1993 to that in 1995?
Your answer should be compact. 1.52. What is the ratio of the Rent(as % of GDP) in Senegal in 1993 to that in 1995?
Offer a terse response. 0.84. What is the ratio of the Rent(as % of GDP) of Yemen, Rep. in 1993 to that in 1995?
Provide a succinct answer. 0.49. What is the ratio of the Rent(as % of GDP) of Fragile and conflict affected situations in 1993 to that in 1996?
Provide a succinct answer. 0.86. What is the ratio of the Rent(as % of GDP) in Peru in 1993 to that in 1996?
Keep it short and to the point. 1.29. What is the ratio of the Rent(as % of GDP) of Senegal in 1993 to that in 1996?
Your answer should be very brief. 0.71. What is the ratio of the Rent(as % of GDP) of Yemen, Rep. in 1993 to that in 1996?
Offer a terse response. 0.55. What is the ratio of the Rent(as % of GDP) in Peru in 1993 to that in 1997?
Give a very brief answer. 1.49. What is the ratio of the Rent(as % of GDP) of Senegal in 1993 to that in 1997?
Keep it short and to the point. 0.7. What is the ratio of the Rent(as % of GDP) of Yemen, Rep. in 1993 to that in 1997?
Provide a succinct answer. 0.66. What is the ratio of the Rent(as % of GDP) in Fragile and conflict affected situations in 1993 to that in 1998?
Ensure brevity in your answer.  1.61. What is the ratio of the Rent(as % of GDP) in Peru in 1993 to that in 1998?
Ensure brevity in your answer.  2.59. What is the ratio of the Rent(as % of GDP) of Senegal in 1993 to that in 1998?
Keep it short and to the point. 0.64. What is the ratio of the Rent(as % of GDP) in Yemen, Rep. in 1993 to that in 1998?
Make the answer very short. 0.96. What is the ratio of the Rent(as % of GDP) in Fragile and conflict affected situations in 1993 to that in 1999?
Your response must be concise. 1.24. What is the ratio of the Rent(as % of GDP) in Peru in 1993 to that in 1999?
Your answer should be compact. 1.72. What is the ratio of the Rent(as % of GDP) of Senegal in 1993 to that in 1999?
Your response must be concise. 0.89. What is the ratio of the Rent(as % of GDP) in Yemen, Rep. in 1993 to that in 1999?
Your answer should be very brief. 0.76. What is the ratio of the Rent(as % of GDP) of Fragile and conflict affected situations in 1994 to that in 1995?
Give a very brief answer. 0.95. What is the ratio of the Rent(as % of GDP) in Peru in 1994 to that in 1995?
Keep it short and to the point. 1.12. What is the ratio of the Rent(as % of GDP) in Senegal in 1994 to that in 1995?
Ensure brevity in your answer.  1.15. What is the ratio of the Rent(as % of GDP) of Yemen, Rep. in 1994 to that in 1995?
Your answer should be compact. 0.9. What is the ratio of the Rent(as % of GDP) of Fragile and conflict affected situations in 1994 to that in 1996?
Provide a succinct answer. 0.84. What is the ratio of the Rent(as % of GDP) in Peru in 1994 to that in 1996?
Make the answer very short. 0.95. What is the ratio of the Rent(as % of GDP) of Senegal in 1994 to that in 1996?
Ensure brevity in your answer.  0.97. What is the ratio of the Rent(as % of GDP) in Yemen, Rep. in 1994 to that in 1996?
Your answer should be very brief. 1.01. What is the ratio of the Rent(as % of GDP) in Fragile and conflict affected situations in 1994 to that in 1997?
Your answer should be very brief. 0.98. What is the ratio of the Rent(as % of GDP) of Peru in 1994 to that in 1997?
Provide a succinct answer. 1.1. What is the ratio of the Rent(as % of GDP) in Senegal in 1994 to that in 1997?
Your answer should be very brief. 0.96. What is the ratio of the Rent(as % of GDP) of Yemen, Rep. in 1994 to that in 1997?
Keep it short and to the point. 1.21. What is the ratio of the Rent(as % of GDP) of Fragile and conflict affected situations in 1994 to that in 1998?
Give a very brief answer. 1.56. What is the ratio of the Rent(as % of GDP) of Peru in 1994 to that in 1998?
Give a very brief answer. 1.91. What is the ratio of the Rent(as % of GDP) of Senegal in 1994 to that in 1998?
Your response must be concise. 0.87. What is the ratio of the Rent(as % of GDP) in Yemen, Rep. in 1994 to that in 1998?
Offer a terse response. 1.77. What is the ratio of the Rent(as % of GDP) in Fragile and conflict affected situations in 1994 to that in 1999?
Your answer should be compact. 1.21. What is the ratio of the Rent(as % of GDP) of Peru in 1994 to that in 1999?
Give a very brief answer. 1.27. What is the ratio of the Rent(as % of GDP) of Senegal in 1994 to that in 1999?
Provide a succinct answer. 1.23. What is the ratio of the Rent(as % of GDP) of Yemen, Rep. in 1994 to that in 1999?
Give a very brief answer. 1.39. What is the ratio of the Rent(as % of GDP) in Fragile and conflict affected situations in 1995 to that in 1996?
Ensure brevity in your answer.  0.88. What is the ratio of the Rent(as % of GDP) of Peru in 1995 to that in 1996?
Provide a succinct answer. 0.85. What is the ratio of the Rent(as % of GDP) in Senegal in 1995 to that in 1996?
Your response must be concise. 0.85. What is the ratio of the Rent(as % of GDP) in Yemen, Rep. in 1995 to that in 1996?
Make the answer very short. 1.12. What is the ratio of the Rent(as % of GDP) of Fragile and conflict affected situations in 1995 to that in 1997?
Provide a succinct answer. 1.03. What is the ratio of the Rent(as % of GDP) of Peru in 1995 to that in 1997?
Ensure brevity in your answer.  0.98. What is the ratio of the Rent(as % of GDP) of Senegal in 1995 to that in 1997?
Ensure brevity in your answer.  0.84. What is the ratio of the Rent(as % of GDP) in Yemen, Rep. in 1995 to that in 1997?
Your response must be concise. 1.34. What is the ratio of the Rent(as % of GDP) in Fragile and conflict affected situations in 1995 to that in 1998?
Keep it short and to the point. 1.65. What is the ratio of the Rent(as % of GDP) of Peru in 1995 to that in 1998?
Your response must be concise. 1.7. What is the ratio of the Rent(as % of GDP) of Senegal in 1995 to that in 1998?
Your answer should be very brief. 0.76. What is the ratio of the Rent(as % of GDP) in Yemen, Rep. in 1995 to that in 1998?
Your answer should be compact. 1.95. What is the ratio of the Rent(as % of GDP) in Fragile and conflict affected situations in 1995 to that in 1999?
Your answer should be very brief. 1.27. What is the ratio of the Rent(as % of GDP) of Peru in 1995 to that in 1999?
Your response must be concise. 1.13. What is the ratio of the Rent(as % of GDP) of Senegal in 1995 to that in 1999?
Offer a terse response. 1.07. What is the ratio of the Rent(as % of GDP) of Yemen, Rep. in 1995 to that in 1999?
Give a very brief answer. 1.54. What is the ratio of the Rent(as % of GDP) in Fragile and conflict affected situations in 1996 to that in 1997?
Offer a terse response. 1.16. What is the ratio of the Rent(as % of GDP) in Peru in 1996 to that in 1997?
Offer a very short reply. 1.15. What is the ratio of the Rent(as % of GDP) of Yemen, Rep. in 1996 to that in 1997?
Provide a short and direct response. 1.2. What is the ratio of the Rent(as % of GDP) of Fragile and conflict affected situations in 1996 to that in 1998?
Your response must be concise. 1.87. What is the ratio of the Rent(as % of GDP) in Peru in 1996 to that in 1998?
Make the answer very short. 2.01. What is the ratio of the Rent(as % of GDP) of Senegal in 1996 to that in 1998?
Your answer should be very brief. 0.9. What is the ratio of the Rent(as % of GDP) in Yemen, Rep. in 1996 to that in 1998?
Provide a short and direct response. 1.75. What is the ratio of the Rent(as % of GDP) in Fragile and conflict affected situations in 1996 to that in 1999?
Ensure brevity in your answer.  1.44. What is the ratio of the Rent(as % of GDP) in Peru in 1996 to that in 1999?
Your response must be concise. 1.33. What is the ratio of the Rent(as % of GDP) of Senegal in 1996 to that in 1999?
Ensure brevity in your answer.  1.27. What is the ratio of the Rent(as % of GDP) of Yemen, Rep. in 1996 to that in 1999?
Give a very brief answer. 1.38. What is the ratio of the Rent(as % of GDP) in Fragile and conflict affected situations in 1997 to that in 1998?
Ensure brevity in your answer.  1.6. What is the ratio of the Rent(as % of GDP) of Peru in 1997 to that in 1998?
Your answer should be compact. 1.74. What is the ratio of the Rent(as % of GDP) in Senegal in 1997 to that in 1998?
Offer a terse response. 0.9. What is the ratio of the Rent(as % of GDP) of Yemen, Rep. in 1997 to that in 1998?
Give a very brief answer. 1.46. What is the ratio of the Rent(as % of GDP) in Fragile and conflict affected situations in 1997 to that in 1999?
Your answer should be compact. 1.24. What is the ratio of the Rent(as % of GDP) in Peru in 1997 to that in 1999?
Ensure brevity in your answer.  1.16. What is the ratio of the Rent(as % of GDP) of Senegal in 1997 to that in 1999?
Provide a short and direct response. 1.27. What is the ratio of the Rent(as % of GDP) in Yemen, Rep. in 1997 to that in 1999?
Keep it short and to the point. 1.15. What is the ratio of the Rent(as % of GDP) in Fragile and conflict affected situations in 1998 to that in 1999?
Provide a succinct answer. 0.77. What is the ratio of the Rent(as % of GDP) in Peru in 1998 to that in 1999?
Give a very brief answer. 0.66. What is the ratio of the Rent(as % of GDP) of Senegal in 1998 to that in 1999?
Your answer should be very brief. 1.41. What is the ratio of the Rent(as % of GDP) of Yemen, Rep. in 1998 to that in 1999?
Make the answer very short. 0.79. What is the difference between the highest and the second highest Rent(as % of GDP) of Fragile and conflict affected situations?
Make the answer very short. 1.44. What is the difference between the highest and the second highest Rent(as % of GDP) in Peru?
Offer a terse response. 0.39. What is the difference between the highest and the second highest Rent(as % of GDP) in Senegal?
Make the answer very short. 0. What is the difference between the highest and the second highest Rent(as % of GDP) of Yemen, Rep.?
Provide a short and direct response. 3.95. What is the difference between the highest and the lowest Rent(as % of GDP) in Fragile and conflict affected situations?
Offer a terse response. 5.72. What is the difference between the highest and the lowest Rent(as % of GDP) of Peru?
Give a very brief answer. 1.06. What is the difference between the highest and the lowest Rent(as % of GDP) in Yemen, Rep.?
Give a very brief answer. 20.84. 